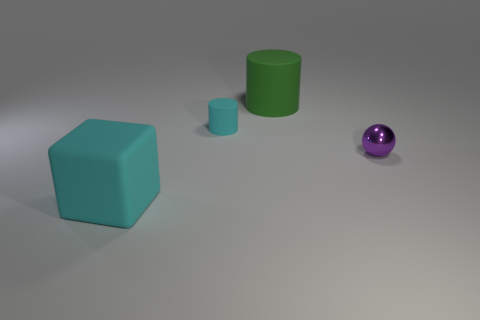Is there any other thing of the same color as the small matte object?
Your answer should be compact. Yes. Are the green object and the cyan object that is in front of the purple shiny sphere made of the same material?
Your answer should be compact. Yes. What material is the tiny cyan thing that is the same shape as the big green matte thing?
Keep it short and to the point. Rubber. Are there any other things that have the same material as the big green thing?
Your answer should be very brief. Yes. Is the material of the large cyan block in front of the small cyan rubber cylinder the same as the small thing to the left of the green object?
Your answer should be very brief. Yes. What is the color of the big matte thing to the left of the large rubber thing that is on the right side of the large object in front of the large green rubber cylinder?
Your response must be concise. Cyan. What number of other objects are there of the same shape as the big cyan thing?
Ensure brevity in your answer.  0. Do the rubber block and the tiny shiny object have the same color?
Offer a terse response. No. How many objects are either cyan matte cylinders or things that are to the left of the tiny sphere?
Your answer should be very brief. 3. Is there a purple object that has the same size as the green matte cylinder?
Your response must be concise. No. 